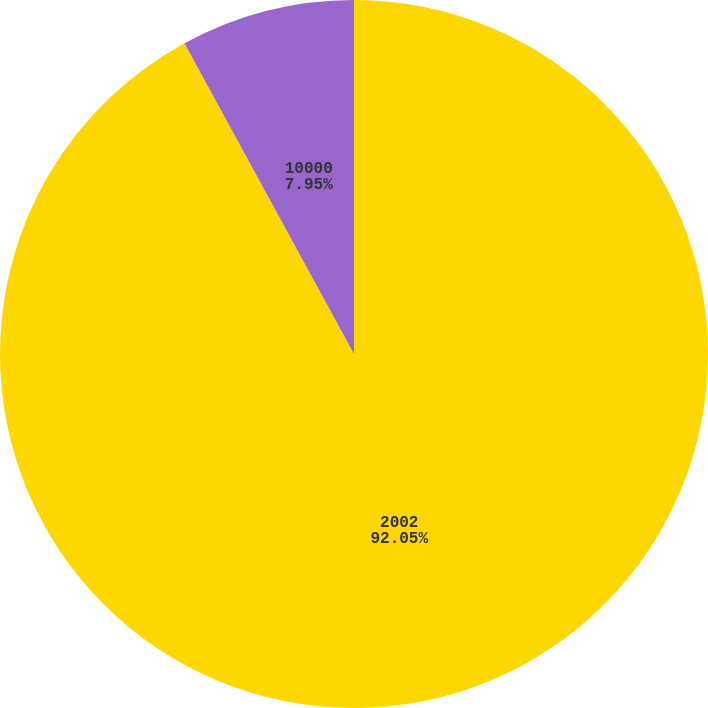Convert chart. <chart><loc_0><loc_0><loc_500><loc_500><pie_chart><fcel>2002<fcel>10000<nl><fcel>92.05%<fcel>7.95%<nl></chart> 